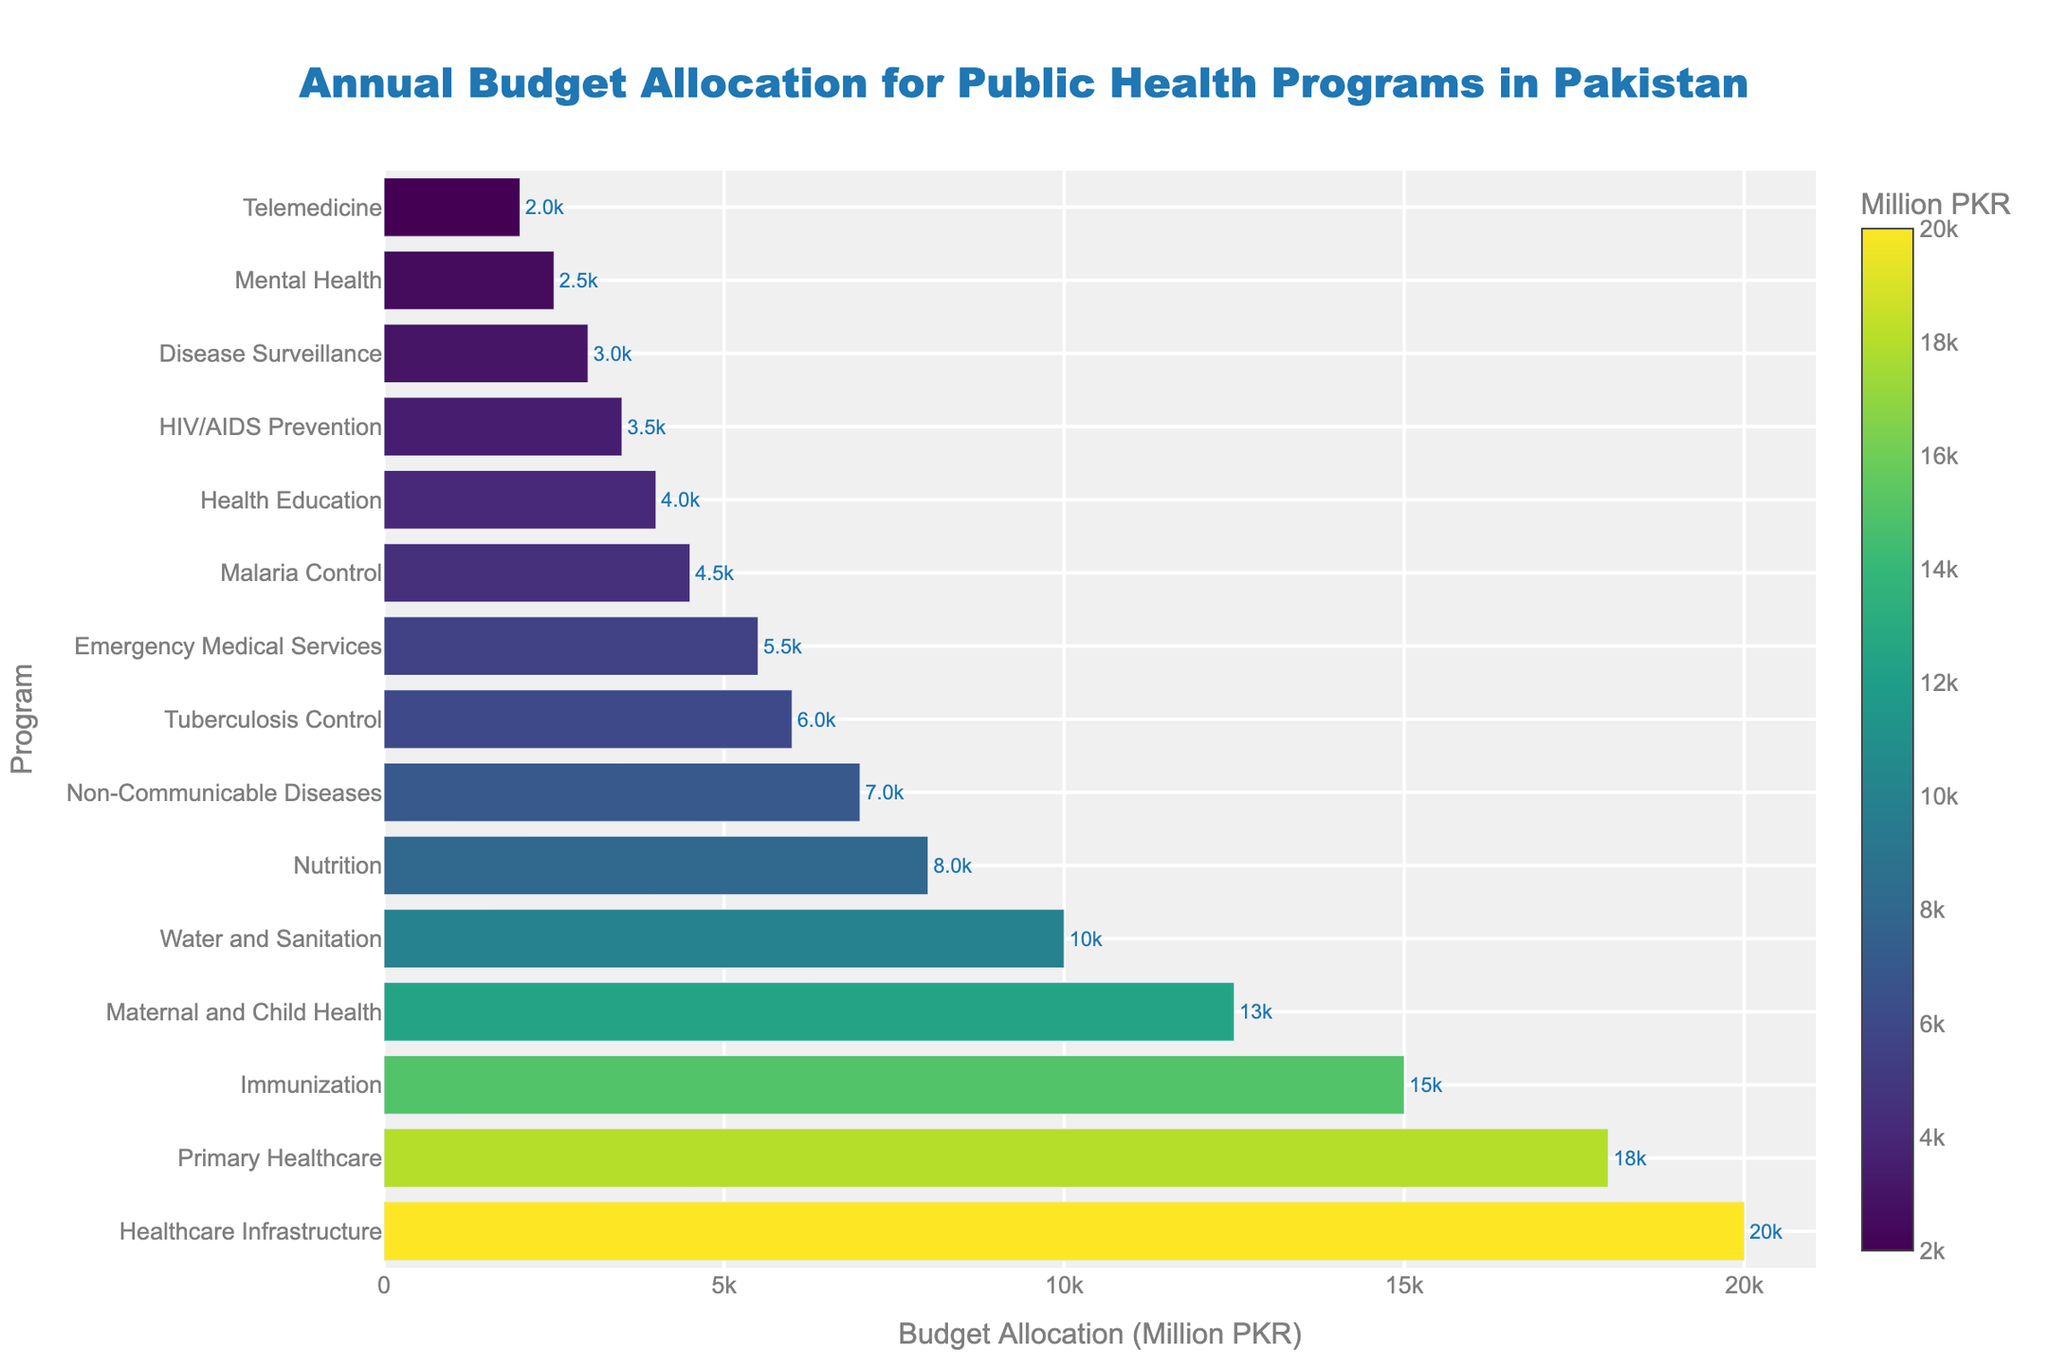Which public health program has the highest budget allocation? By inspecting the bar lengths, we see that the 'Healthcare Infrastructure' program has the longest bar, indicating the highest budget allocation.
Answer: Healthcare Infrastructure What is the difference in budget allocation between Primary Healthcare and Non-Communicable Diseases? The bar for Primary Healthcare is labeled with an allocation of 18,000 million PKR, while the bar for Non-Communicable Diseases is labeled with 7,000 million PKR. The difference is 18,000 - 7,000.
Answer: 11,000 million PKR Which program has a higher budget allocation: Malaria Control or Tuberculosis Control? Comparing the bar lengths, Tuberculosis Control has a budget of 6,000 million PKR, while Malaria Control has 4,500 million PKR. Tuberculosis Control has a higher allocation.
Answer: Tuberculosis Control How much more is allocated to Immunization compared to Nutrition? Immunization has an allocation of 15,000 million PKR and Nutrition has 8,000 million PKR. The difference is calculated as 15,000 - 8,000.
Answer: 7,000 million PKR What is the total budget allocation for Emergency Medical Services, Water and Sanitation, and Health Education? Adding the budget allocations for these programs: Emergency Medical Services (5,500), Water and Sanitation (10,000), and Health Education (4,000) gives 5,500 + 10,000 + 4,000.
Answer: 19,500 million PKR What percentage of the total budget is allocated to Mental Health? First, sum all the budget allocations, then calculate the percentage for Mental Health. Total budget is 118,000 million PKR. Mental Health is 2,500 million PKR. Percentage = (2,500 / 118,000) * 100.
Answer: 2.12% What is the combined budget allocation for programs related to child and maternal health (Immunization and Maternal and Child Health)? Sum the budgets for Immunization (15,000) and Maternal and Child Health (12,500): 15,000 + 12,500.
Answer: 27,500 million PKR Which program has the lowest budget allocation? By inspecting the shortest bar, the 'Mental Health' program has the shortest bar, indicating the lowest budget allocation.
Answer: Mental Health If the budget for HIV/AIDS Prevention were doubled, what would the new total budget for this program be? The current allocation for HIV/AIDS Prevention is 3,500 million PKR. Doubling it would be 3,500 * 2.
Answer: 7,000 million PKR How does the budget allocation for Telemedicine compare to Disease Surveillance? The budget allocation for Telemedicine is 2,000 million PKR and for Disease Surveillance is 3,000 million PKR. Disease Surveillance has a higher budget allocation.
Answer: Disease Surveillance 